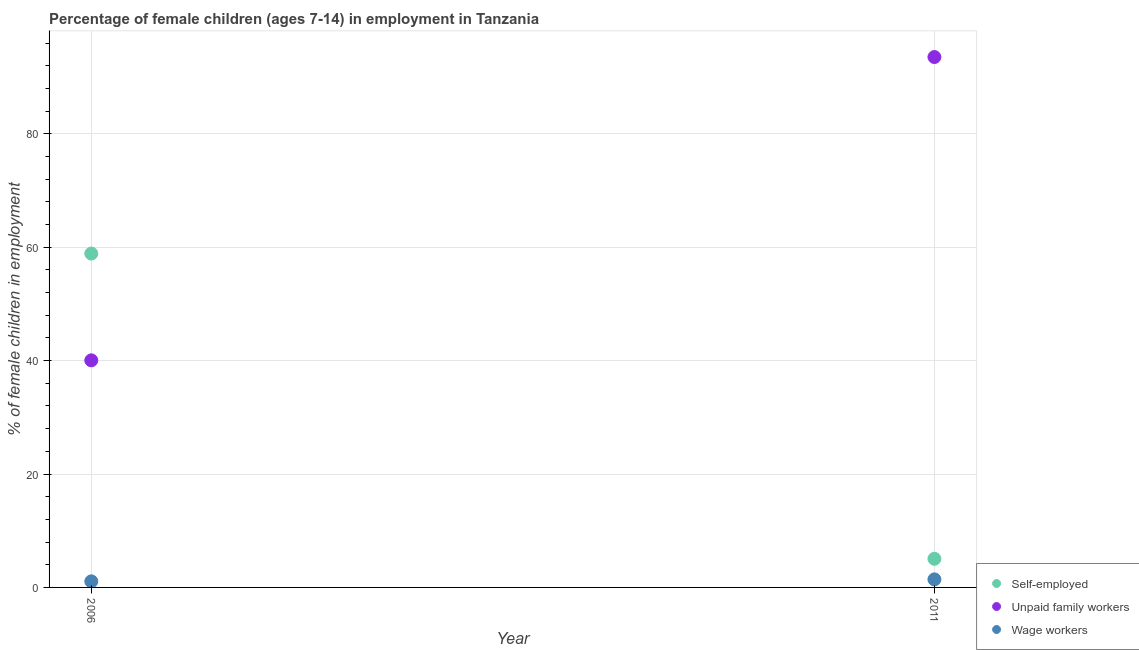Is the number of dotlines equal to the number of legend labels?
Your answer should be very brief. Yes. What is the percentage of children employed as wage workers in 2011?
Ensure brevity in your answer.  1.42. Across all years, what is the maximum percentage of children employed as wage workers?
Give a very brief answer. 1.42. Across all years, what is the minimum percentage of children employed as wage workers?
Your response must be concise. 1.07. In which year was the percentage of children employed as unpaid family workers maximum?
Your answer should be very brief. 2011. In which year was the percentage of children employed as unpaid family workers minimum?
Make the answer very short. 2006. What is the total percentage of children employed as wage workers in the graph?
Provide a succinct answer. 2.49. What is the difference between the percentage of children employed as unpaid family workers in 2006 and that in 2011?
Provide a short and direct response. -53.49. What is the difference between the percentage of children employed as unpaid family workers in 2011 and the percentage of self employed children in 2006?
Offer a very short reply. 34.66. What is the average percentage of children employed as wage workers per year?
Provide a short and direct response. 1.25. In the year 2011, what is the difference between the percentage of children employed as unpaid family workers and percentage of self employed children?
Keep it short and to the point. 88.49. What is the ratio of the percentage of self employed children in 2006 to that in 2011?
Your response must be concise. 11.66. Is the percentage of children employed as unpaid family workers in 2006 less than that in 2011?
Your answer should be compact. Yes. In how many years, is the percentage of children employed as wage workers greater than the average percentage of children employed as wage workers taken over all years?
Make the answer very short. 1. Is it the case that in every year, the sum of the percentage of self employed children and percentage of children employed as unpaid family workers is greater than the percentage of children employed as wage workers?
Offer a very short reply. Yes. Is the percentage of self employed children strictly greater than the percentage of children employed as unpaid family workers over the years?
Offer a very short reply. No. How many dotlines are there?
Offer a terse response. 3. How many years are there in the graph?
Keep it short and to the point. 2. Are the values on the major ticks of Y-axis written in scientific E-notation?
Give a very brief answer. No. Does the graph contain any zero values?
Provide a succinct answer. No. Where does the legend appear in the graph?
Give a very brief answer. Bottom right. How many legend labels are there?
Offer a very short reply. 3. How are the legend labels stacked?
Your answer should be very brief. Vertical. What is the title of the graph?
Give a very brief answer. Percentage of female children (ages 7-14) in employment in Tanzania. Does "Natural Gas" appear as one of the legend labels in the graph?
Make the answer very short. No. What is the label or title of the Y-axis?
Offer a very short reply. % of female children in employment. What is the % of female children in employment of Self-employed in 2006?
Ensure brevity in your answer.  58.88. What is the % of female children in employment in Unpaid family workers in 2006?
Offer a terse response. 40.05. What is the % of female children in employment of Wage workers in 2006?
Give a very brief answer. 1.07. What is the % of female children in employment of Self-employed in 2011?
Your response must be concise. 5.05. What is the % of female children in employment in Unpaid family workers in 2011?
Provide a short and direct response. 93.54. What is the % of female children in employment of Wage workers in 2011?
Make the answer very short. 1.42. Across all years, what is the maximum % of female children in employment in Self-employed?
Provide a succinct answer. 58.88. Across all years, what is the maximum % of female children in employment in Unpaid family workers?
Provide a succinct answer. 93.54. Across all years, what is the maximum % of female children in employment of Wage workers?
Keep it short and to the point. 1.42. Across all years, what is the minimum % of female children in employment in Self-employed?
Give a very brief answer. 5.05. Across all years, what is the minimum % of female children in employment in Unpaid family workers?
Make the answer very short. 40.05. Across all years, what is the minimum % of female children in employment of Wage workers?
Keep it short and to the point. 1.07. What is the total % of female children in employment in Self-employed in the graph?
Offer a terse response. 63.93. What is the total % of female children in employment of Unpaid family workers in the graph?
Make the answer very short. 133.59. What is the total % of female children in employment of Wage workers in the graph?
Give a very brief answer. 2.49. What is the difference between the % of female children in employment of Self-employed in 2006 and that in 2011?
Give a very brief answer. 53.83. What is the difference between the % of female children in employment in Unpaid family workers in 2006 and that in 2011?
Your answer should be very brief. -53.49. What is the difference between the % of female children in employment of Wage workers in 2006 and that in 2011?
Make the answer very short. -0.35. What is the difference between the % of female children in employment in Self-employed in 2006 and the % of female children in employment in Unpaid family workers in 2011?
Ensure brevity in your answer.  -34.66. What is the difference between the % of female children in employment of Self-employed in 2006 and the % of female children in employment of Wage workers in 2011?
Your answer should be compact. 57.46. What is the difference between the % of female children in employment of Unpaid family workers in 2006 and the % of female children in employment of Wage workers in 2011?
Your response must be concise. 38.63. What is the average % of female children in employment in Self-employed per year?
Make the answer very short. 31.96. What is the average % of female children in employment in Unpaid family workers per year?
Your answer should be compact. 66.8. What is the average % of female children in employment in Wage workers per year?
Your answer should be compact. 1.25. In the year 2006, what is the difference between the % of female children in employment of Self-employed and % of female children in employment of Unpaid family workers?
Your response must be concise. 18.83. In the year 2006, what is the difference between the % of female children in employment of Self-employed and % of female children in employment of Wage workers?
Ensure brevity in your answer.  57.81. In the year 2006, what is the difference between the % of female children in employment in Unpaid family workers and % of female children in employment in Wage workers?
Make the answer very short. 38.98. In the year 2011, what is the difference between the % of female children in employment of Self-employed and % of female children in employment of Unpaid family workers?
Your response must be concise. -88.49. In the year 2011, what is the difference between the % of female children in employment of Self-employed and % of female children in employment of Wage workers?
Your response must be concise. 3.63. In the year 2011, what is the difference between the % of female children in employment of Unpaid family workers and % of female children in employment of Wage workers?
Offer a terse response. 92.12. What is the ratio of the % of female children in employment in Self-employed in 2006 to that in 2011?
Provide a short and direct response. 11.66. What is the ratio of the % of female children in employment of Unpaid family workers in 2006 to that in 2011?
Keep it short and to the point. 0.43. What is the ratio of the % of female children in employment of Wage workers in 2006 to that in 2011?
Provide a short and direct response. 0.75. What is the difference between the highest and the second highest % of female children in employment in Self-employed?
Offer a very short reply. 53.83. What is the difference between the highest and the second highest % of female children in employment in Unpaid family workers?
Make the answer very short. 53.49. What is the difference between the highest and the lowest % of female children in employment of Self-employed?
Your answer should be very brief. 53.83. What is the difference between the highest and the lowest % of female children in employment in Unpaid family workers?
Offer a very short reply. 53.49. 